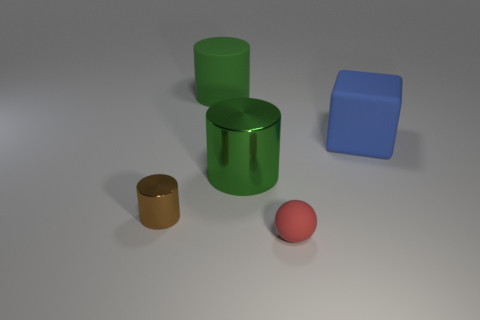The tiny shiny thing has what color?
Ensure brevity in your answer.  Brown. Is the size of the red object the same as the brown cylinder?
Offer a terse response. Yes. Are there any other things that are the same shape as the brown metal thing?
Your answer should be very brief. Yes. Do the small red ball and the green thing that is behind the blue matte thing have the same material?
Offer a very short reply. Yes. Does the tiny object right of the large rubber cylinder have the same color as the big rubber cube?
Make the answer very short. No. How many things are right of the brown shiny cylinder and in front of the green metallic object?
Give a very brief answer. 1. What number of other objects are there of the same material as the small red sphere?
Ensure brevity in your answer.  2. Are the tiny thing that is in front of the brown thing and the big blue thing made of the same material?
Offer a very short reply. Yes. What is the size of the green cylinder that is on the right side of the big matte thing that is on the left side of the green thing in front of the blue rubber object?
Provide a succinct answer. Large. How many other things are the same color as the sphere?
Offer a terse response. 0. 